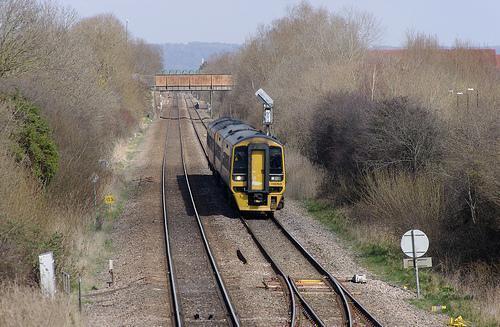How many trains are there?
Give a very brief answer. 1. 